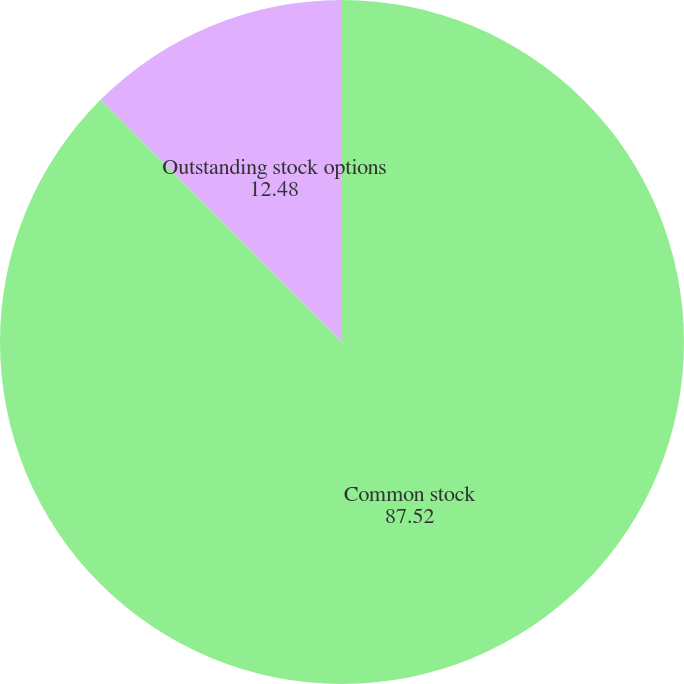Convert chart to OTSL. <chart><loc_0><loc_0><loc_500><loc_500><pie_chart><fcel>Common stock<fcel>Outstanding stock options<nl><fcel>87.52%<fcel>12.48%<nl></chart> 